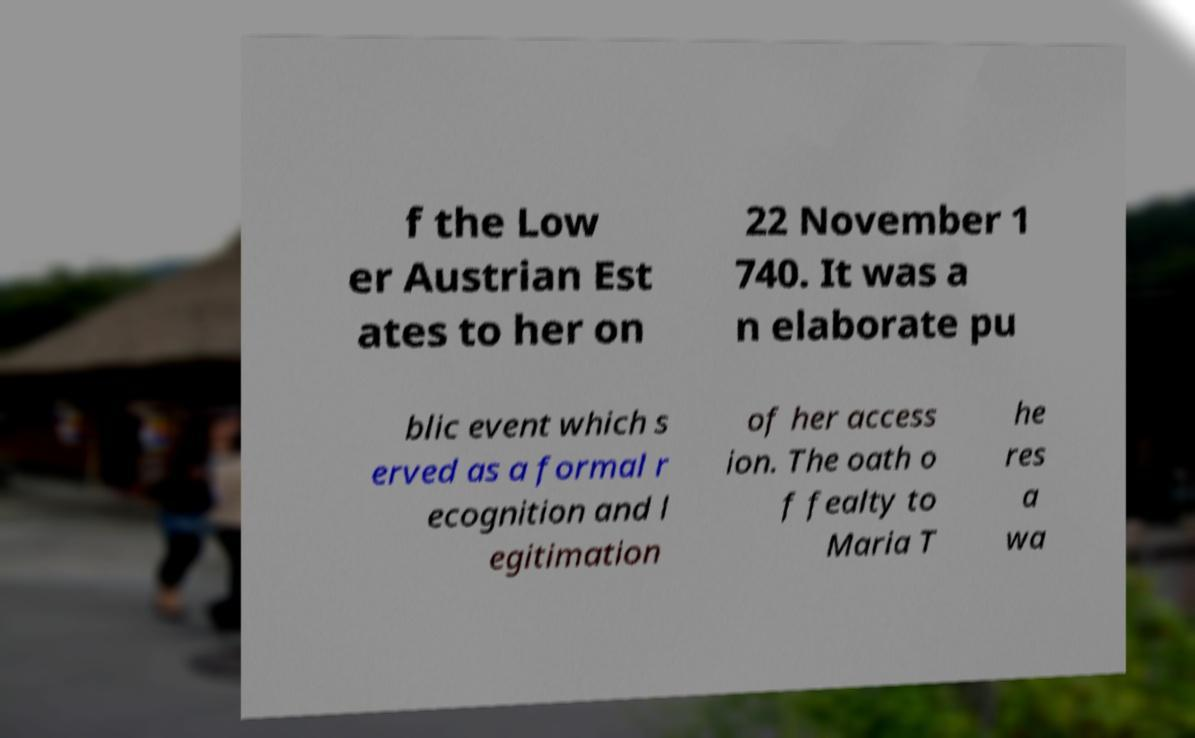Could you assist in decoding the text presented in this image and type it out clearly? f the Low er Austrian Est ates to her on 22 November 1 740. It was a n elaborate pu blic event which s erved as a formal r ecognition and l egitimation of her access ion. The oath o f fealty to Maria T he res a wa 